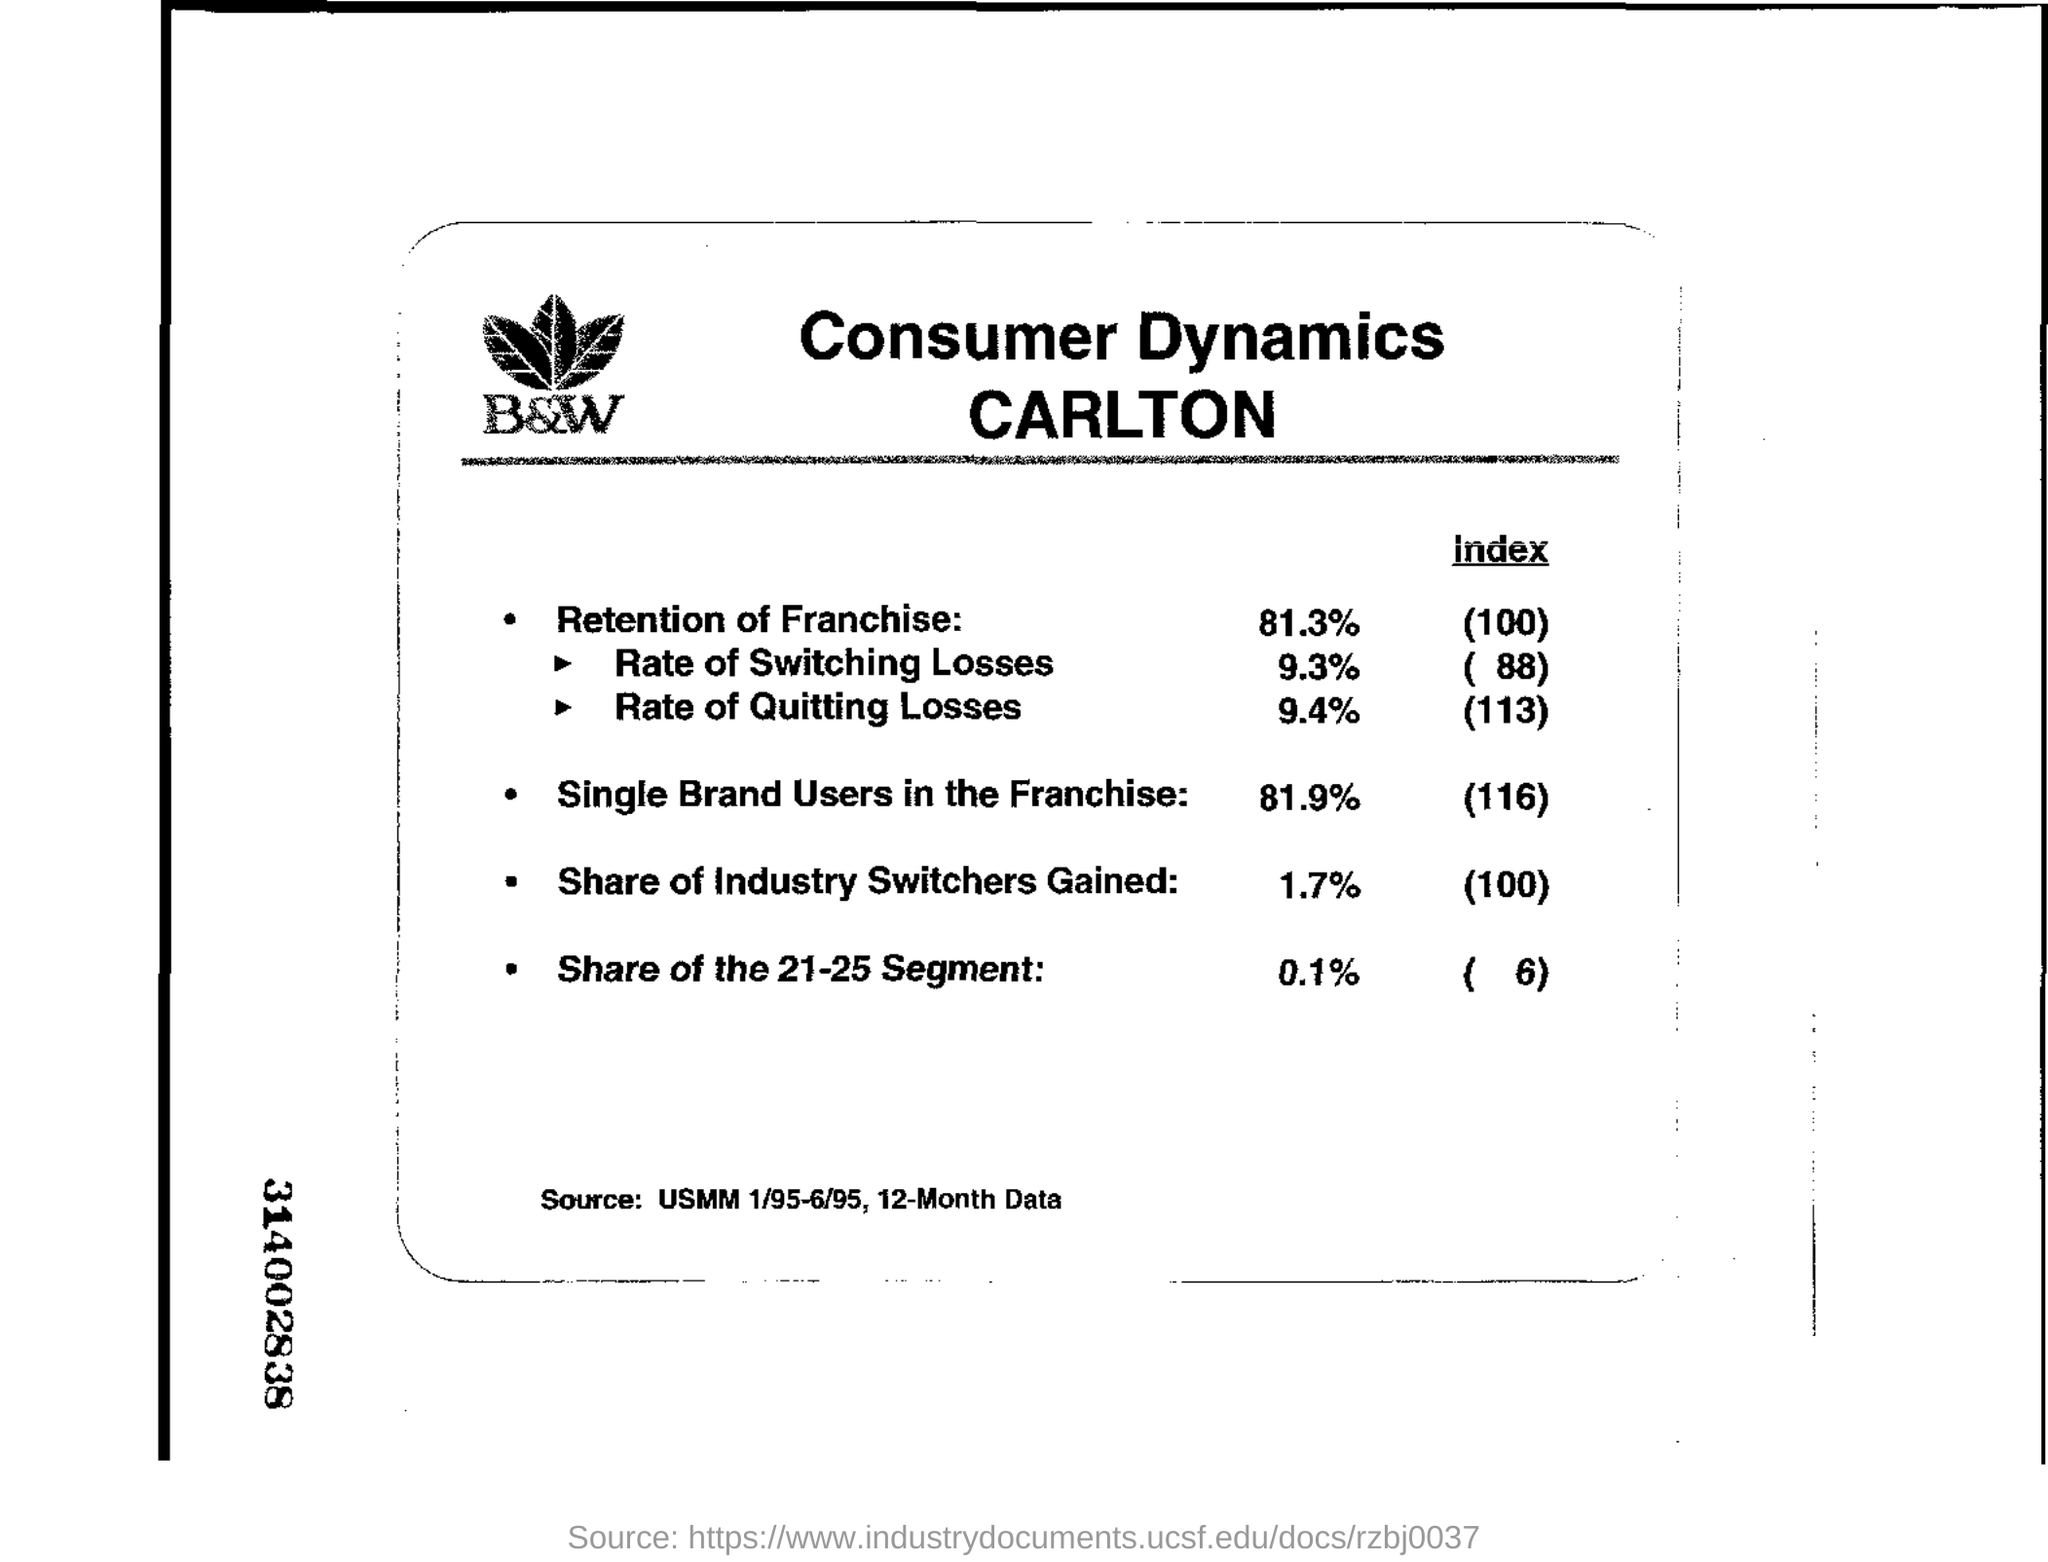What is the index for retention of franchise
Provide a short and direct response. 100. What is the source
Your answer should be very brief. USMM 1/95-6/95, 12-Month Data. The number mentioned on the right of the leftside margin?
Your response must be concise. 314002838. 